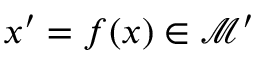Convert formula to latex. <formula><loc_0><loc_0><loc_500><loc_500>x ^ { \prime } = f ( x ) \in \mathcal { M } ^ { \prime }</formula> 